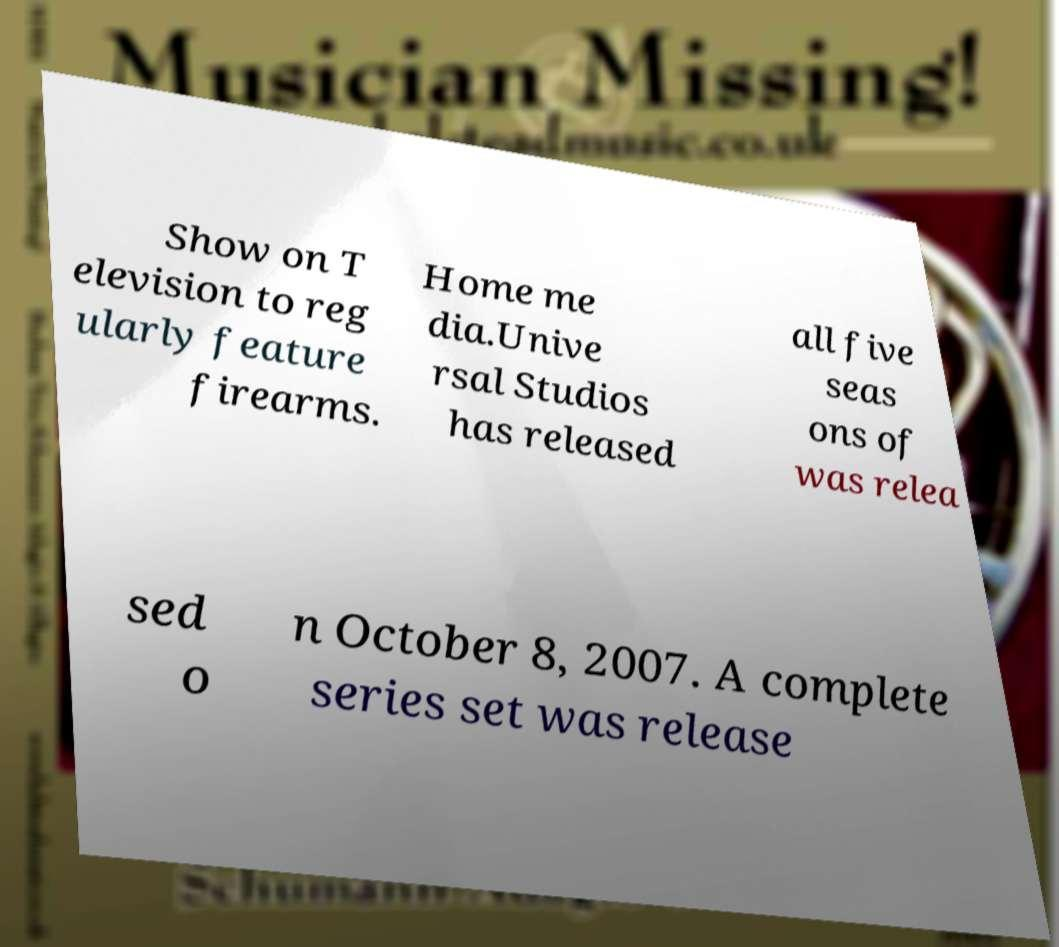Can you accurately transcribe the text from the provided image for me? Show on T elevision to reg ularly feature firearms. Home me dia.Unive rsal Studios has released all five seas ons of was relea sed o n October 8, 2007. A complete series set was release 